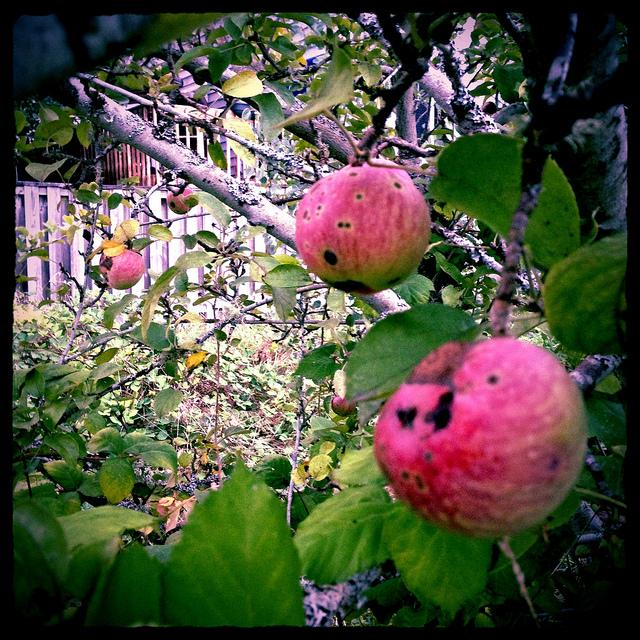Why are there black spots on the apples?

Choices:
A) fresh
B) painted
C) stained
D) rotting rotting 